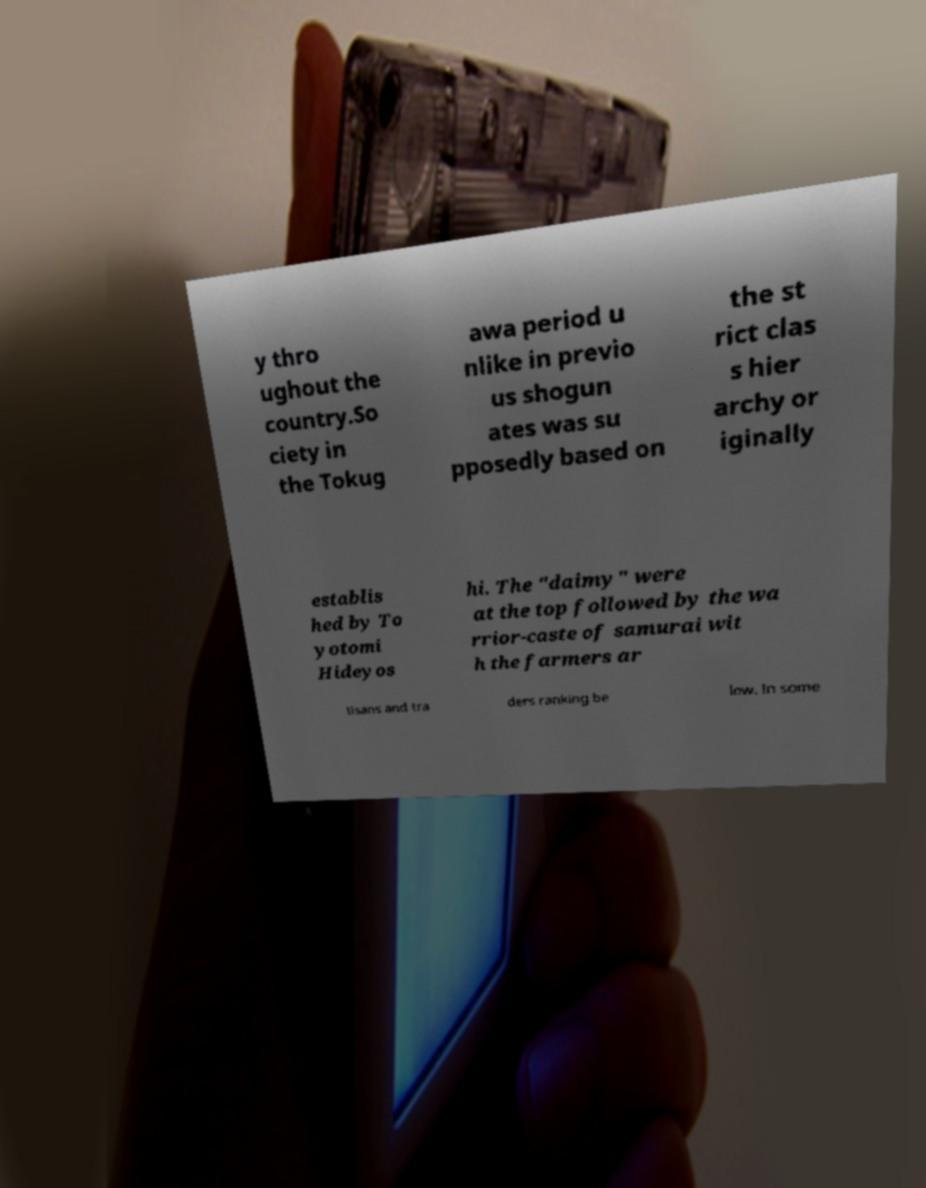There's text embedded in this image that I need extracted. Can you transcribe it verbatim? y thro ughout the country.So ciety in the Tokug awa period u nlike in previo us shogun ates was su pposedly based on the st rict clas s hier archy or iginally establis hed by To yotomi Hideyos hi. The "daimy" were at the top followed by the wa rrior-caste of samurai wit h the farmers ar tisans and tra ders ranking be low. In some 